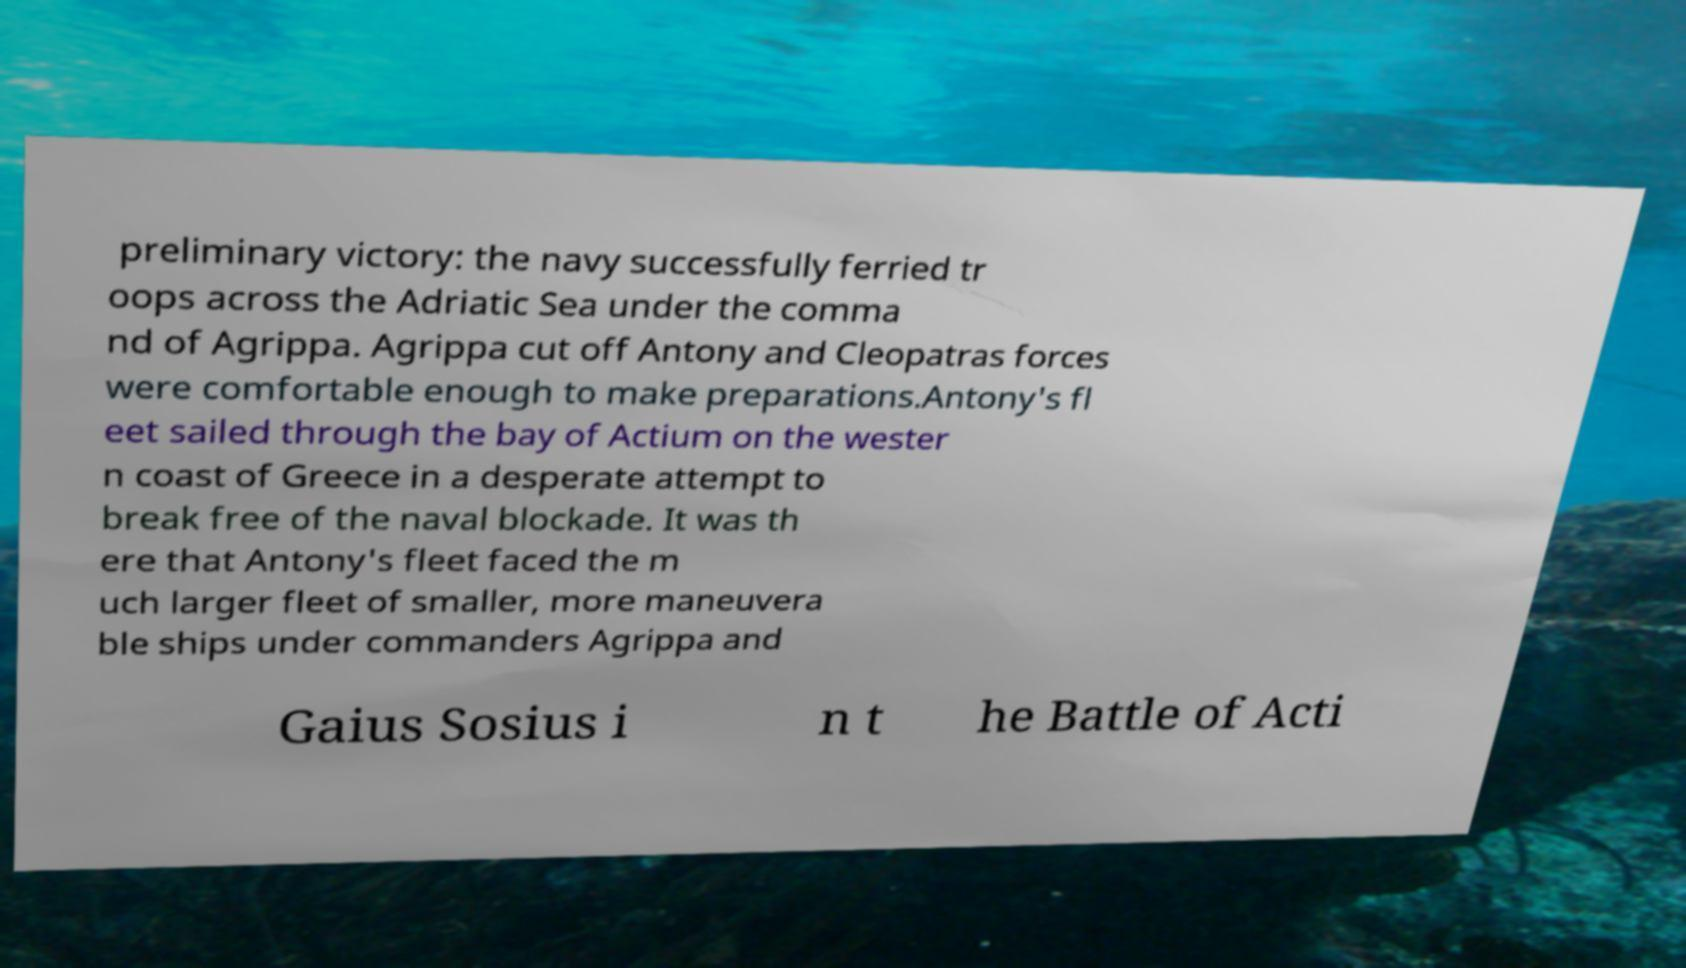Can you read and provide the text displayed in the image?This photo seems to have some interesting text. Can you extract and type it out for me? preliminary victory: the navy successfully ferried tr oops across the Adriatic Sea under the comma nd of Agrippa. Agrippa cut off Antony and Cleopatras forces were comfortable enough to make preparations.Antony's fl eet sailed through the bay of Actium on the wester n coast of Greece in a desperate attempt to break free of the naval blockade. It was th ere that Antony's fleet faced the m uch larger fleet of smaller, more maneuvera ble ships under commanders Agrippa and Gaius Sosius i n t he Battle of Acti 